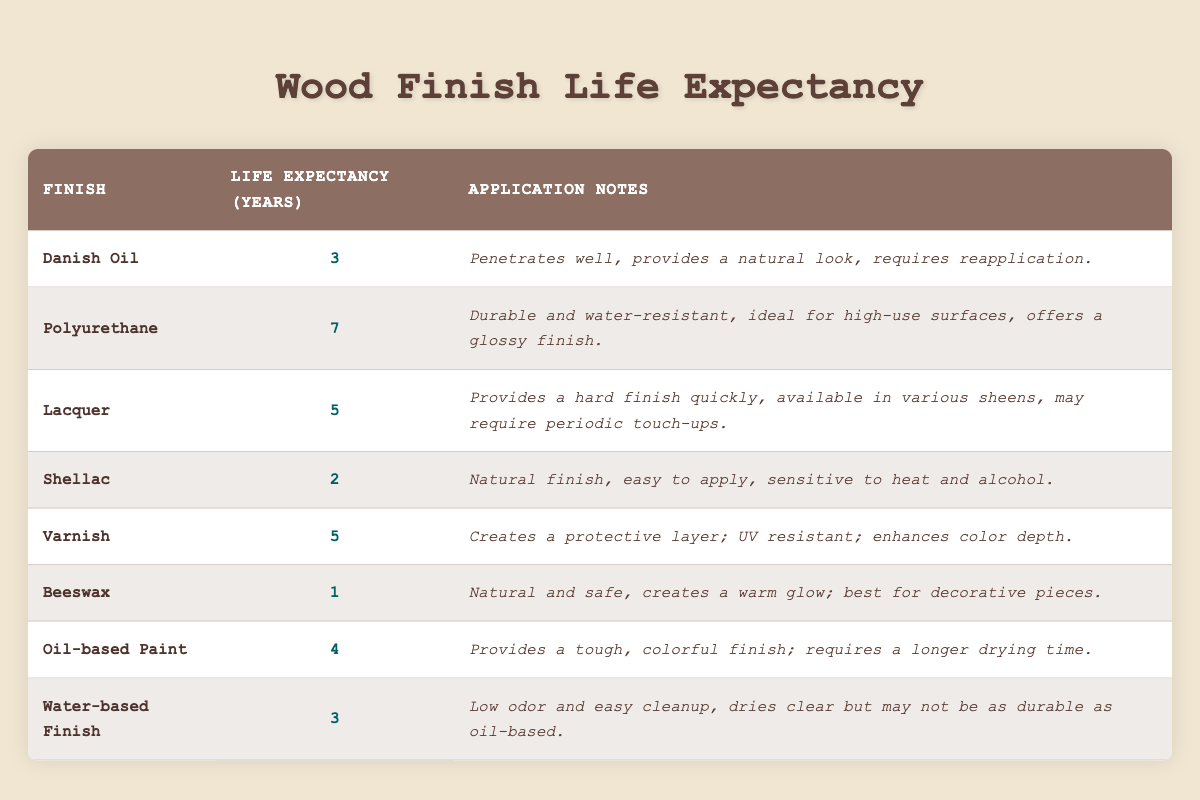What is the life expectancy of Polyurethane? The table lists the life expectancy of finishes, and for Polyurethane, it shows 7 years.
Answer: 7 years Which finish has the shortest life expectancy? By checking the life expectancy values in the table, Beeswax has the shortest life expectancy at 1 year.
Answer: Beeswax What is the average life expectancy of all finishes? To find the average, sum the life expectancies (3 + 7 + 5 + 2 + 5 + 1 + 4 + 3 = 30) and divide by the number of finishes (8). The average is 30 / 8 = 3.75 years.
Answer: 3.75 years Is Shellac more durable than Danish Oil? The life expectancy of Shellac is 2 years, while Danish Oil is 3 years, indicating that Danish Oil is more durable.
Answer: No How many finishes have a life expectancy of 5 years or more? The finishes with life expectancies of 5 years or more are Polyurethane (7), Lacquer (5), and Varnish (5), which totals three finishes.
Answer: 3 finishes What is the difference in life expectancy between Oil-based Paint and Shellac? Oil-based Paint has a life expectancy of 4 years, while Shellac has a life expectancy of 2 years. The difference is calculated as 4 - 2 = 2 years, meaning Oil-based Paint lasts 2 years longer than Shellac.
Answer: 2 years Which finishes can be expected to last less than 3 years? By reviewing the table, the finishes that last less than 3 years are Shellac (2 years) and Beeswax (1 year).
Answer: Shellac and Beeswax If you use a finish with a life expectancy of 5 years, how many more years can you expect it to last compared to Beeswax? Finishes with a life expectancy of 5 years are Lacquer and Varnish. Since Beeswax lasts 1 year, the additional longevity of Lacquer (5) or Varnish (5) compared to Beeswax (1) is calculated as 5 - 1 = 4 years. Both Lacquer and Varnish last 4 years longer.
Answer: 4 years What application notes are provided for Varnish? According to the table, the application notes for Varnish are that it creates a protective layer, is UV resistant, and enhances color depth.
Answer: Protective layer; UV resistant; enhances color depth 